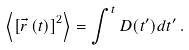Convert formula to latex. <formula><loc_0><loc_0><loc_500><loc_500>\left < \left [ \vec { r } \, ( t ) \right ] ^ { 2 } \right > = \int ^ { t } D ( t ^ { \prime } ) d t ^ { \prime } \, .</formula> 